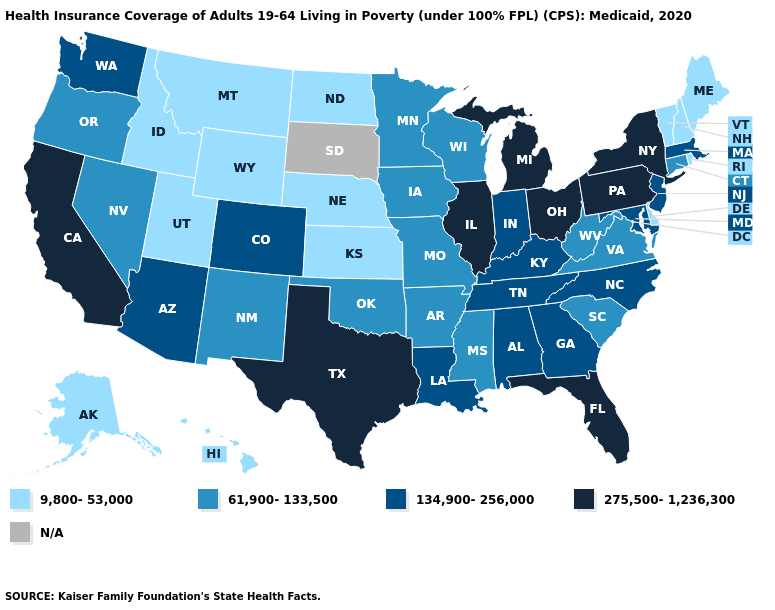What is the lowest value in states that border Utah?
Short answer required. 9,800-53,000. What is the lowest value in the West?
Be succinct. 9,800-53,000. What is the highest value in the USA?
Keep it brief. 275,500-1,236,300. Among the states that border Illinois , does Missouri have the lowest value?
Give a very brief answer. Yes. What is the value of Connecticut?
Write a very short answer. 61,900-133,500. How many symbols are there in the legend?
Answer briefly. 5. Does Nevada have the highest value in the USA?
Give a very brief answer. No. Name the states that have a value in the range N/A?
Give a very brief answer. South Dakota. Does Michigan have the lowest value in the MidWest?
Short answer required. No. Among the states that border Oregon , does California have the lowest value?
Write a very short answer. No. What is the highest value in the Northeast ?
Give a very brief answer. 275,500-1,236,300. Which states have the lowest value in the MidWest?
Quick response, please. Kansas, Nebraska, North Dakota. Does the first symbol in the legend represent the smallest category?
Concise answer only. Yes. Which states have the highest value in the USA?
Answer briefly. California, Florida, Illinois, Michigan, New York, Ohio, Pennsylvania, Texas. 